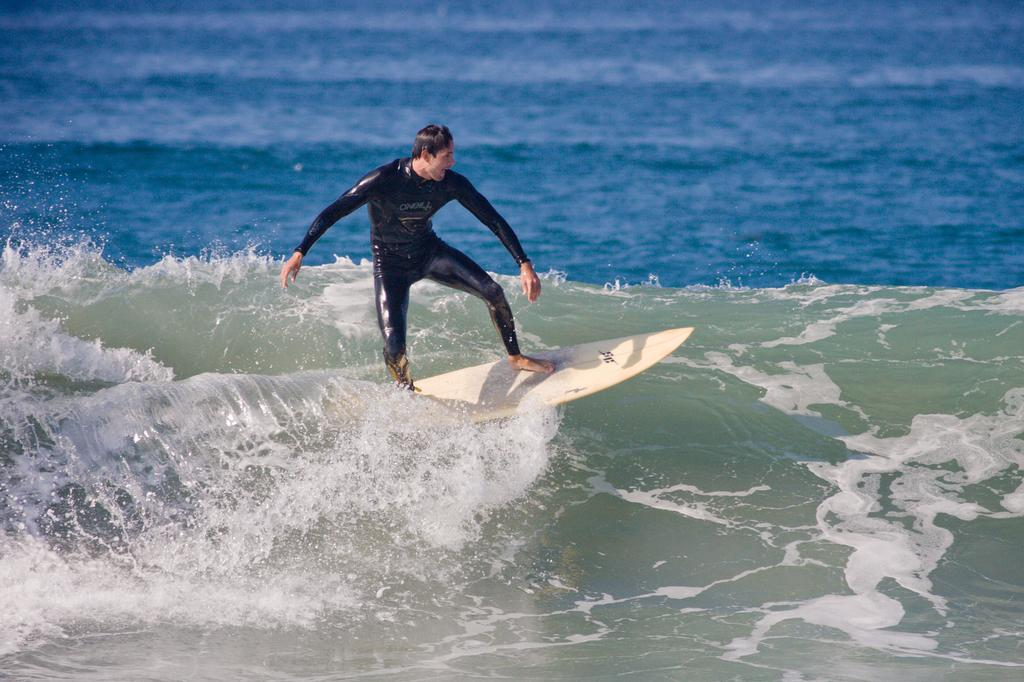Who is the main subject in the image? There is a person in the image. What is the person doing in the image? The person is surfing. What body of water is visible in the image? There is an ocean in the image. What type of story can be seen unfolding in the image? There is no story present in the image; it is a snapshot of a person surfing in an ocean. 